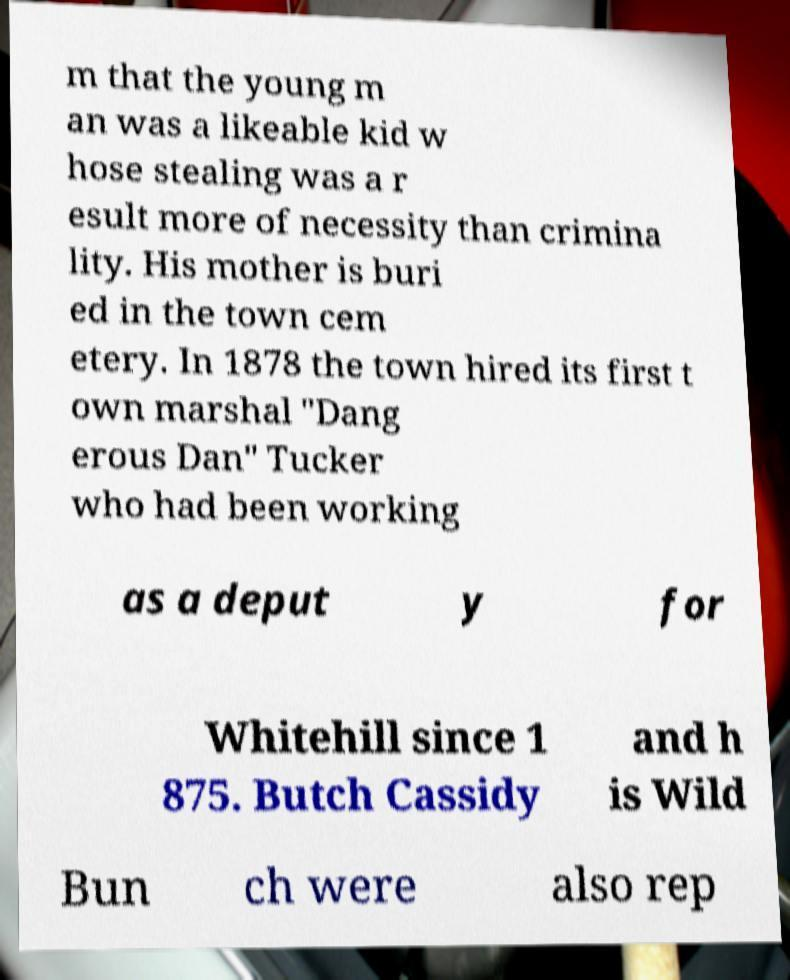Can you accurately transcribe the text from the provided image for me? m that the young m an was a likeable kid w hose stealing was a r esult more of necessity than crimina lity. His mother is buri ed in the town cem etery. In 1878 the town hired its first t own marshal "Dang erous Dan" Tucker who had been working as a deput y for Whitehill since 1 875. Butch Cassidy and h is Wild Bun ch were also rep 